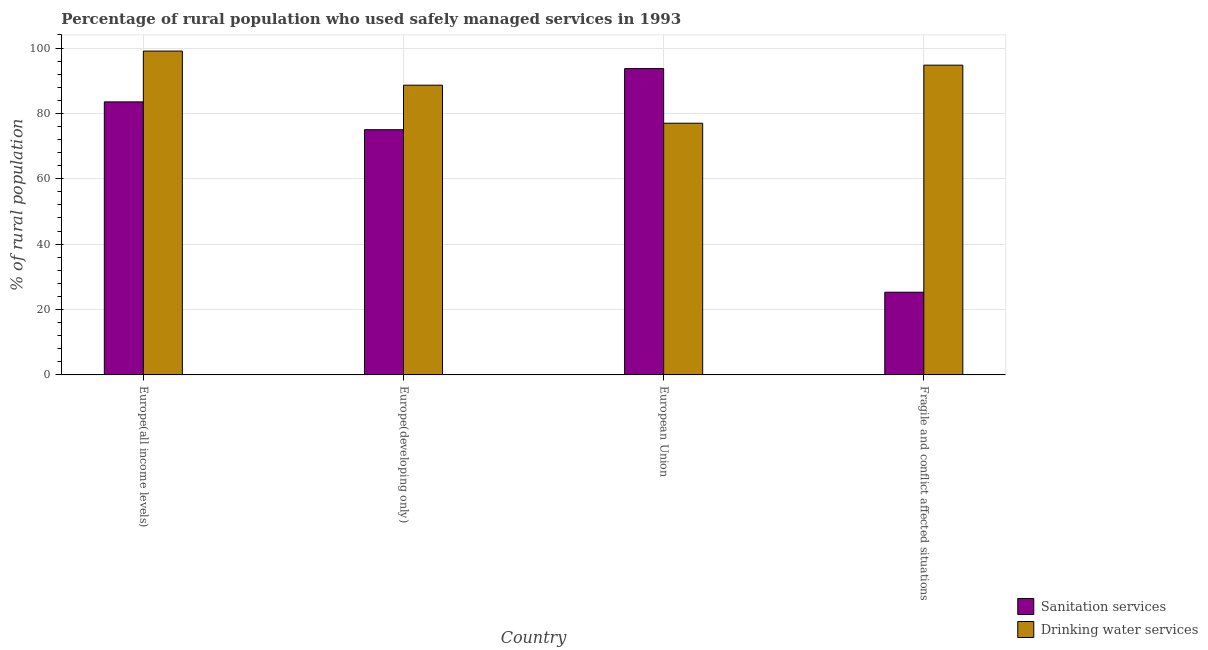How many bars are there on the 3rd tick from the right?
Offer a terse response. 2. What is the label of the 4th group of bars from the left?
Make the answer very short. Fragile and conflict affected situations. In how many cases, is the number of bars for a given country not equal to the number of legend labels?
Offer a terse response. 0. What is the percentage of rural population who used drinking water services in Europe(all income levels)?
Keep it short and to the point. 99.06. Across all countries, what is the maximum percentage of rural population who used drinking water services?
Offer a terse response. 99.06. Across all countries, what is the minimum percentage of rural population who used sanitation services?
Your answer should be compact. 25.29. In which country was the percentage of rural population who used drinking water services maximum?
Keep it short and to the point. Europe(all income levels). In which country was the percentage of rural population who used sanitation services minimum?
Ensure brevity in your answer.  Fragile and conflict affected situations. What is the total percentage of rural population who used drinking water services in the graph?
Your response must be concise. 359.43. What is the difference between the percentage of rural population who used drinking water services in Europe(all income levels) and that in European Union?
Your answer should be compact. 22.08. What is the difference between the percentage of rural population who used drinking water services in European Union and the percentage of rural population who used sanitation services in Europe(all income levels)?
Provide a short and direct response. -6.53. What is the average percentage of rural population who used drinking water services per country?
Give a very brief answer. 89.86. What is the difference between the percentage of rural population who used drinking water services and percentage of rural population who used sanitation services in Fragile and conflict affected situations?
Your answer should be very brief. 69.46. In how many countries, is the percentage of rural population who used sanitation services greater than 80 %?
Give a very brief answer. 2. What is the ratio of the percentage of rural population who used drinking water services in Europe(all income levels) to that in European Union?
Provide a short and direct response. 1.29. Is the percentage of rural population who used sanitation services in European Union less than that in Fragile and conflict affected situations?
Your answer should be compact. No. What is the difference between the highest and the second highest percentage of rural population who used sanitation services?
Provide a succinct answer. 10.19. What is the difference between the highest and the lowest percentage of rural population who used drinking water services?
Your response must be concise. 22.08. In how many countries, is the percentage of rural population who used drinking water services greater than the average percentage of rural population who used drinking water services taken over all countries?
Keep it short and to the point. 2. What does the 1st bar from the left in Fragile and conflict affected situations represents?
Ensure brevity in your answer.  Sanitation services. What does the 1st bar from the right in Europe(all income levels) represents?
Offer a very short reply. Drinking water services. How many bars are there?
Offer a very short reply. 8. Are the values on the major ticks of Y-axis written in scientific E-notation?
Your answer should be very brief. No. Where does the legend appear in the graph?
Provide a succinct answer. Bottom right. How many legend labels are there?
Your response must be concise. 2. How are the legend labels stacked?
Provide a succinct answer. Vertical. What is the title of the graph?
Your answer should be very brief. Percentage of rural population who used safely managed services in 1993. Does "Boys" appear as one of the legend labels in the graph?
Ensure brevity in your answer.  No. What is the label or title of the X-axis?
Make the answer very short. Country. What is the label or title of the Y-axis?
Keep it short and to the point. % of rural population. What is the % of rural population of Sanitation services in Europe(all income levels)?
Make the answer very short. 83.52. What is the % of rural population in Drinking water services in Europe(all income levels)?
Provide a short and direct response. 99.06. What is the % of rural population in Sanitation services in Europe(developing only)?
Provide a succinct answer. 75.01. What is the % of rural population in Drinking water services in Europe(developing only)?
Keep it short and to the point. 88.62. What is the % of rural population of Sanitation services in European Union?
Provide a succinct answer. 93.71. What is the % of rural population of Drinking water services in European Union?
Offer a very short reply. 76.99. What is the % of rural population of Sanitation services in Fragile and conflict affected situations?
Give a very brief answer. 25.29. What is the % of rural population of Drinking water services in Fragile and conflict affected situations?
Your answer should be compact. 94.75. Across all countries, what is the maximum % of rural population in Sanitation services?
Offer a terse response. 93.71. Across all countries, what is the maximum % of rural population of Drinking water services?
Make the answer very short. 99.06. Across all countries, what is the minimum % of rural population of Sanitation services?
Ensure brevity in your answer.  25.29. Across all countries, what is the minimum % of rural population in Drinking water services?
Your response must be concise. 76.99. What is the total % of rural population of Sanitation services in the graph?
Provide a succinct answer. 277.53. What is the total % of rural population of Drinking water services in the graph?
Offer a very short reply. 359.43. What is the difference between the % of rural population of Sanitation services in Europe(all income levels) and that in Europe(developing only)?
Offer a terse response. 8.51. What is the difference between the % of rural population of Drinking water services in Europe(all income levels) and that in Europe(developing only)?
Ensure brevity in your answer.  10.44. What is the difference between the % of rural population of Sanitation services in Europe(all income levels) and that in European Union?
Your answer should be very brief. -10.19. What is the difference between the % of rural population of Drinking water services in Europe(all income levels) and that in European Union?
Provide a short and direct response. 22.08. What is the difference between the % of rural population of Sanitation services in Europe(all income levels) and that in Fragile and conflict affected situations?
Your answer should be compact. 58.23. What is the difference between the % of rural population of Drinking water services in Europe(all income levels) and that in Fragile and conflict affected situations?
Give a very brief answer. 4.31. What is the difference between the % of rural population in Sanitation services in Europe(developing only) and that in European Union?
Your response must be concise. -18.7. What is the difference between the % of rural population of Drinking water services in Europe(developing only) and that in European Union?
Your answer should be very brief. 11.64. What is the difference between the % of rural population of Sanitation services in Europe(developing only) and that in Fragile and conflict affected situations?
Give a very brief answer. 49.72. What is the difference between the % of rural population of Drinking water services in Europe(developing only) and that in Fragile and conflict affected situations?
Make the answer very short. -6.13. What is the difference between the % of rural population of Sanitation services in European Union and that in Fragile and conflict affected situations?
Your answer should be very brief. 68.41. What is the difference between the % of rural population in Drinking water services in European Union and that in Fragile and conflict affected situations?
Offer a terse response. -17.76. What is the difference between the % of rural population of Sanitation services in Europe(all income levels) and the % of rural population of Drinking water services in Europe(developing only)?
Provide a succinct answer. -5.1. What is the difference between the % of rural population in Sanitation services in Europe(all income levels) and the % of rural population in Drinking water services in European Union?
Make the answer very short. 6.53. What is the difference between the % of rural population in Sanitation services in Europe(all income levels) and the % of rural population in Drinking water services in Fragile and conflict affected situations?
Provide a short and direct response. -11.23. What is the difference between the % of rural population in Sanitation services in Europe(developing only) and the % of rural population in Drinking water services in European Union?
Your answer should be compact. -1.98. What is the difference between the % of rural population in Sanitation services in Europe(developing only) and the % of rural population in Drinking water services in Fragile and conflict affected situations?
Keep it short and to the point. -19.74. What is the difference between the % of rural population in Sanitation services in European Union and the % of rural population in Drinking water services in Fragile and conflict affected situations?
Your answer should be compact. -1.04. What is the average % of rural population of Sanitation services per country?
Offer a terse response. 69.38. What is the average % of rural population in Drinking water services per country?
Ensure brevity in your answer.  89.86. What is the difference between the % of rural population of Sanitation services and % of rural population of Drinking water services in Europe(all income levels)?
Your answer should be very brief. -15.54. What is the difference between the % of rural population in Sanitation services and % of rural population in Drinking water services in Europe(developing only)?
Your answer should be very brief. -13.62. What is the difference between the % of rural population of Sanitation services and % of rural population of Drinking water services in European Union?
Your answer should be compact. 16.72. What is the difference between the % of rural population of Sanitation services and % of rural population of Drinking water services in Fragile and conflict affected situations?
Give a very brief answer. -69.46. What is the ratio of the % of rural population of Sanitation services in Europe(all income levels) to that in Europe(developing only)?
Your answer should be compact. 1.11. What is the ratio of the % of rural population in Drinking water services in Europe(all income levels) to that in Europe(developing only)?
Offer a very short reply. 1.12. What is the ratio of the % of rural population of Sanitation services in Europe(all income levels) to that in European Union?
Keep it short and to the point. 0.89. What is the ratio of the % of rural population of Drinking water services in Europe(all income levels) to that in European Union?
Keep it short and to the point. 1.29. What is the ratio of the % of rural population in Sanitation services in Europe(all income levels) to that in Fragile and conflict affected situations?
Keep it short and to the point. 3.3. What is the ratio of the % of rural population in Drinking water services in Europe(all income levels) to that in Fragile and conflict affected situations?
Provide a short and direct response. 1.05. What is the ratio of the % of rural population of Sanitation services in Europe(developing only) to that in European Union?
Offer a very short reply. 0.8. What is the ratio of the % of rural population in Drinking water services in Europe(developing only) to that in European Union?
Your response must be concise. 1.15. What is the ratio of the % of rural population in Sanitation services in Europe(developing only) to that in Fragile and conflict affected situations?
Offer a very short reply. 2.97. What is the ratio of the % of rural population in Drinking water services in Europe(developing only) to that in Fragile and conflict affected situations?
Make the answer very short. 0.94. What is the ratio of the % of rural population in Sanitation services in European Union to that in Fragile and conflict affected situations?
Make the answer very short. 3.7. What is the ratio of the % of rural population of Drinking water services in European Union to that in Fragile and conflict affected situations?
Offer a very short reply. 0.81. What is the difference between the highest and the second highest % of rural population of Sanitation services?
Provide a short and direct response. 10.19. What is the difference between the highest and the second highest % of rural population in Drinking water services?
Offer a very short reply. 4.31. What is the difference between the highest and the lowest % of rural population in Sanitation services?
Make the answer very short. 68.41. What is the difference between the highest and the lowest % of rural population of Drinking water services?
Make the answer very short. 22.08. 